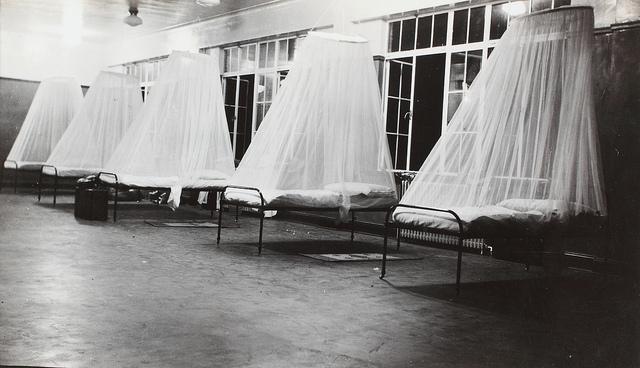How many beds are in the room?
Give a very brief answer. 5. How many beds are there?
Give a very brief answer. 5. How many beds can you see?
Give a very brief answer. 5. 